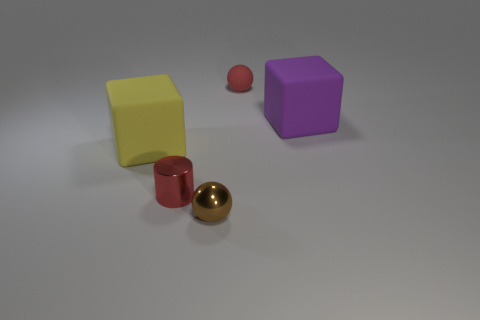What is the material of the other large thing that is the same shape as the big purple rubber thing?
Provide a succinct answer. Rubber. Is the size of the purple matte thing the same as the sphere in front of the large purple block?
Provide a succinct answer. No. Is there a big thing that has the same color as the tiny matte ball?
Your response must be concise. No. How many tiny objects are cyan cubes or red balls?
Provide a short and direct response. 1. What number of large purple cubes are there?
Provide a short and direct response. 1. There is a tiny red thing that is in front of the tiny rubber thing; what is it made of?
Your answer should be very brief. Metal. There is a tiny brown object; are there any yellow objects to the right of it?
Offer a very short reply. No. Is the red metal object the same size as the brown ball?
Give a very brief answer. Yes. How many large purple things are made of the same material as the brown object?
Provide a succinct answer. 0. There is a matte block to the right of the tiny thing that is behind the big purple thing; how big is it?
Keep it short and to the point. Large. 